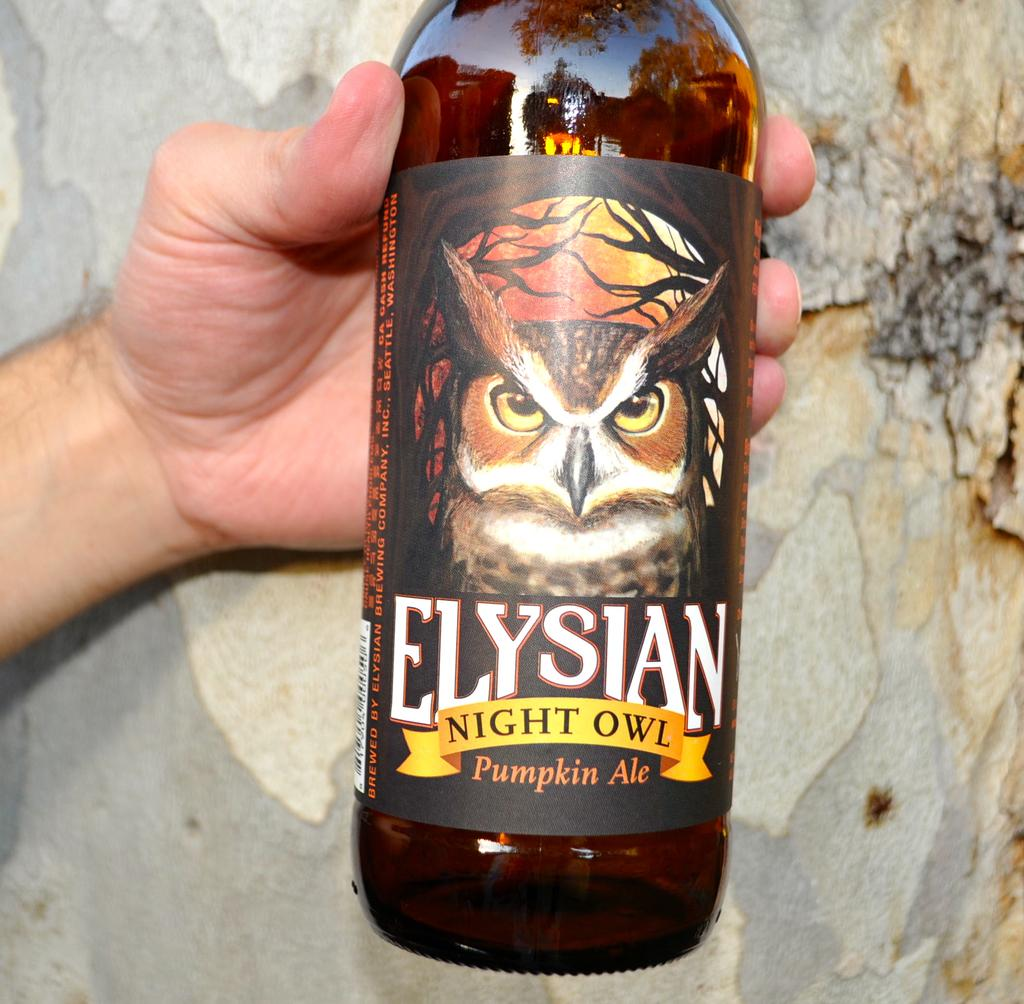<image>
Summarize the visual content of the image. A hand is holding Elysian Night Owl Pumpkin Ale. 